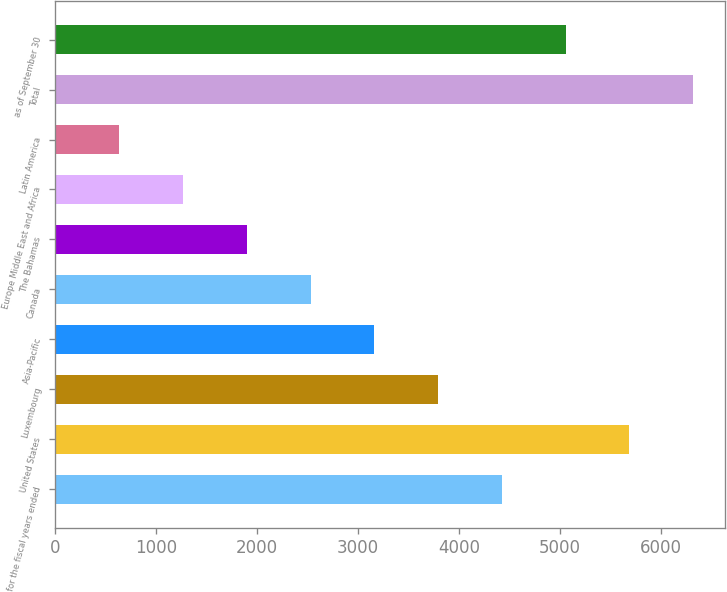<chart> <loc_0><loc_0><loc_500><loc_500><bar_chart><fcel>for the fiscal years ended<fcel>United States<fcel>Luxembourg<fcel>Asia-Pacific<fcel>Canada<fcel>The Bahamas<fcel>Europe Middle East and Africa<fcel>Latin America<fcel>Total<fcel>as of September 30<nl><fcel>4426.4<fcel>5688.2<fcel>3795.5<fcel>3164.6<fcel>2533.7<fcel>1902.8<fcel>1271.9<fcel>641<fcel>6319.1<fcel>5057.3<nl></chart> 